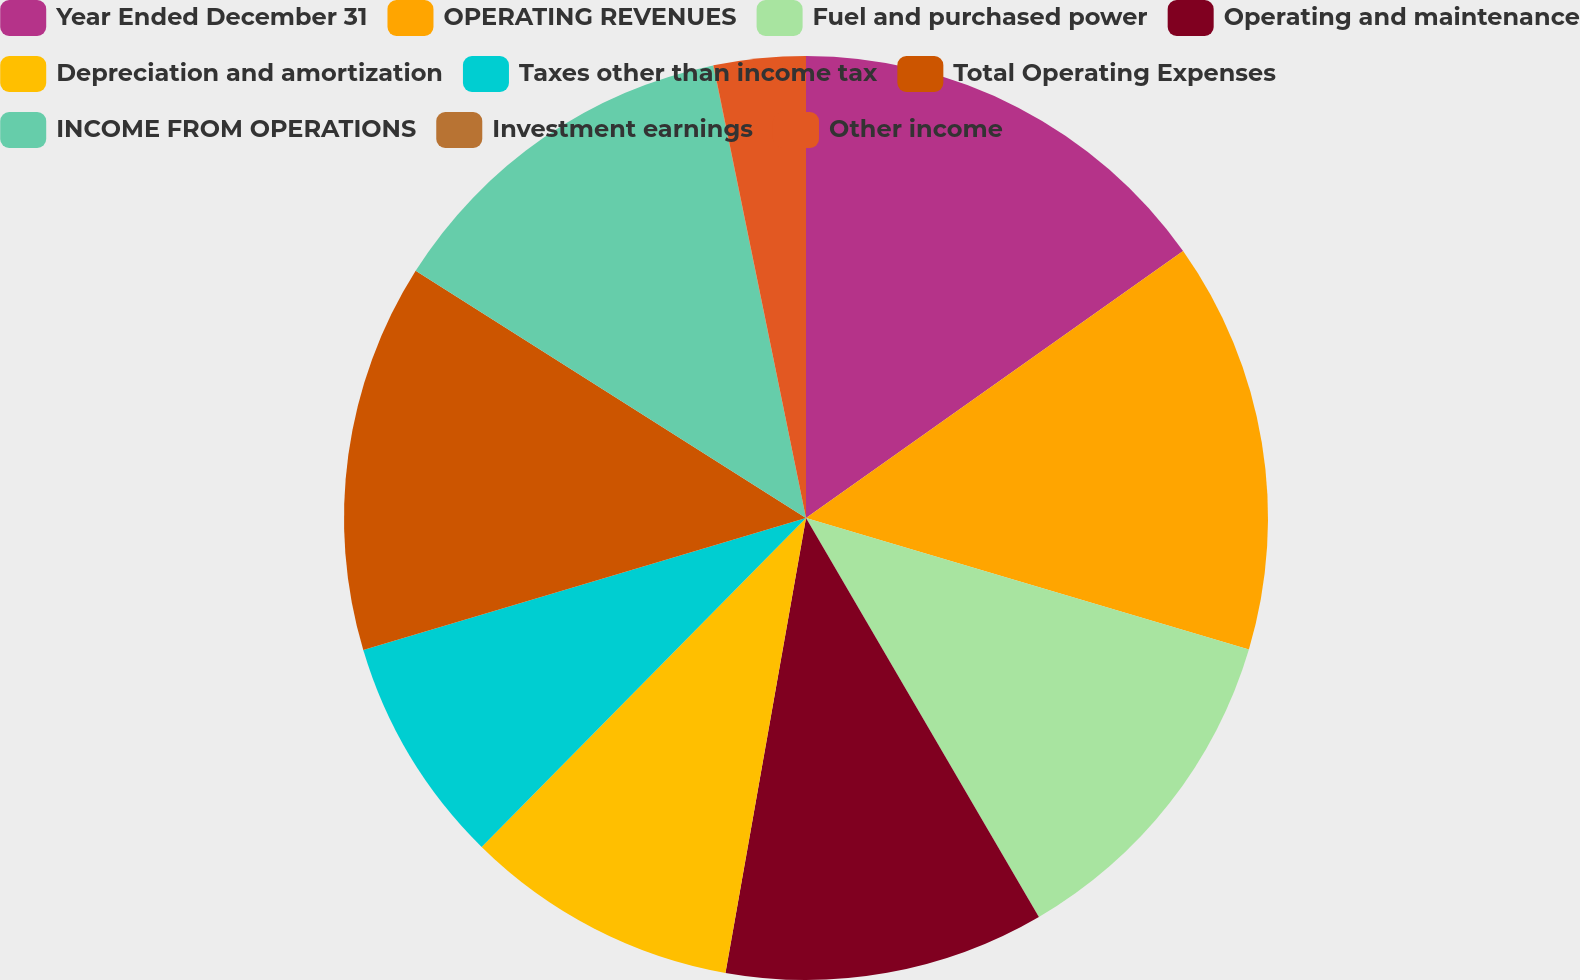Convert chart to OTSL. <chart><loc_0><loc_0><loc_500><loc_500><pie_chart><fcel>Year Ended December 31<fcel>OPERATING REVENUES<fcel>Fuel and purchased power<fcel>Operating and maintenance<fcel>Depreciation and amortization<fcel>Taxes other than income tax<fcel>Total Operating Expenses<fcel>INCOME FROM OPERATIONS<fcel>Investment earnings<fcel>Other income<nl><fcel>15.2%<fcel>14.4%<fcel>12.0%<fcel>11.2%<fcel>9.6%<fcel>8.0%<fcel>13.6%<fcel>12.8%<fcel>0.01%<fcel>3.21%<nl></chart> 